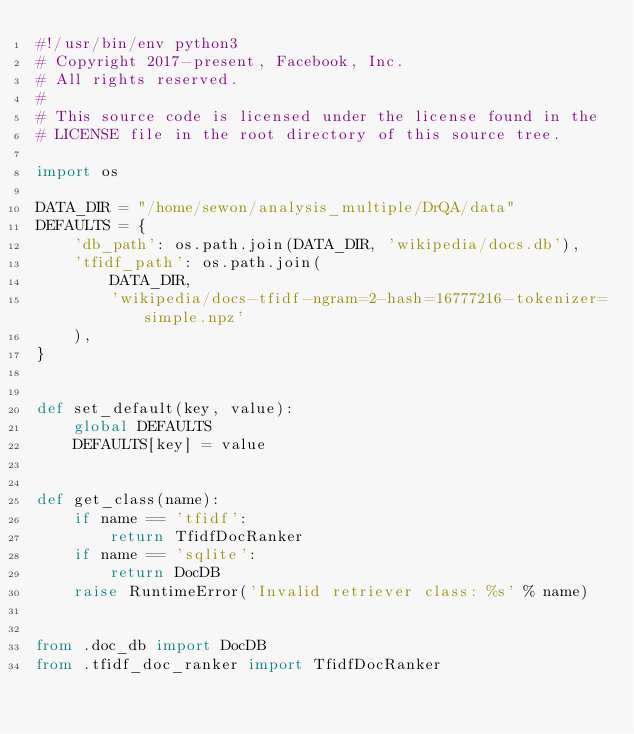<code> <loc_0><loc_0><loc_500><loc_500><_Python_>#!/usr/bin/env python3
# Copyright 2017-present, Facebook, Inc.
# All rights reserved.
#
# This source code is licensed under the license found in the
# LICENSE file in the root directory of this source tree.

import os

DATA_DIR = "/home/sewon/analysis_multiple/DrQA/data"
DEFAULTS = {
    'db_path': os.path.join(DATA_DIR, 'wikipedia/docs.db'),
    'tfidf_path': os.path.join(
        DATA_DIR,
        'wikipedia/docs-tfidf-ngram=2-hash=16777216-tokenizer=simple.npz'
    ),
}


def set_default(key, value):
    global DEFAULTS
    DEFAULTS[key] = value


def get_class(name):
    if name == 'tfidf':
        return TfidfDocRanker
    if name == 'sqlite':
        return DocDB
    raise RuntimeError('Invalid retriever class: %s' % name)


from .doc_db import DocDB
from .tfidf_doc_ranker import TfidfDocRanker
</code> 